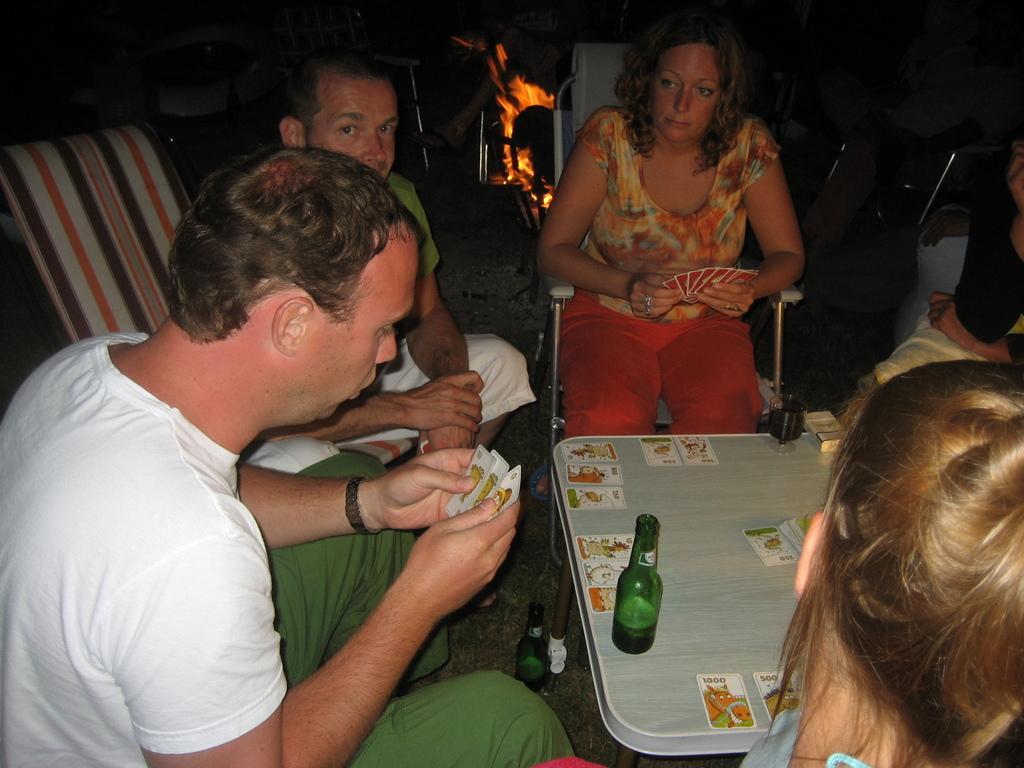Describe this image in one or two sentences. In this image i can see few people playing cards, and on the table i can see a glass and few cards, in the background i can see camp fire and few chairs. 